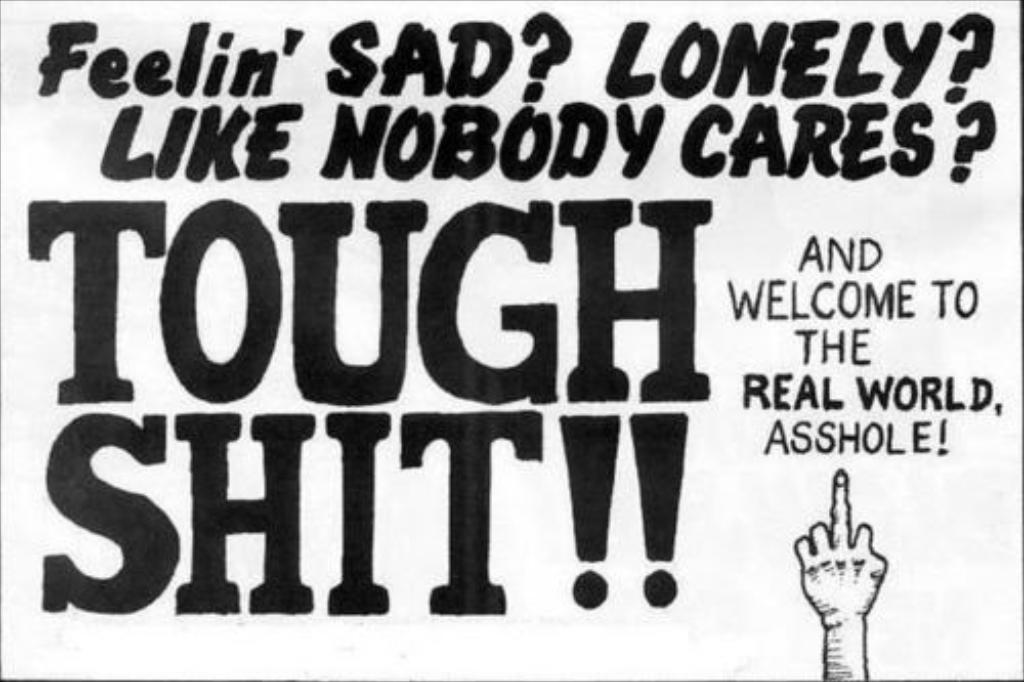What is tough?
Provide a short and direct response. Shit. What is the finger pointing to?
Offer a very short reply. Asshole. 